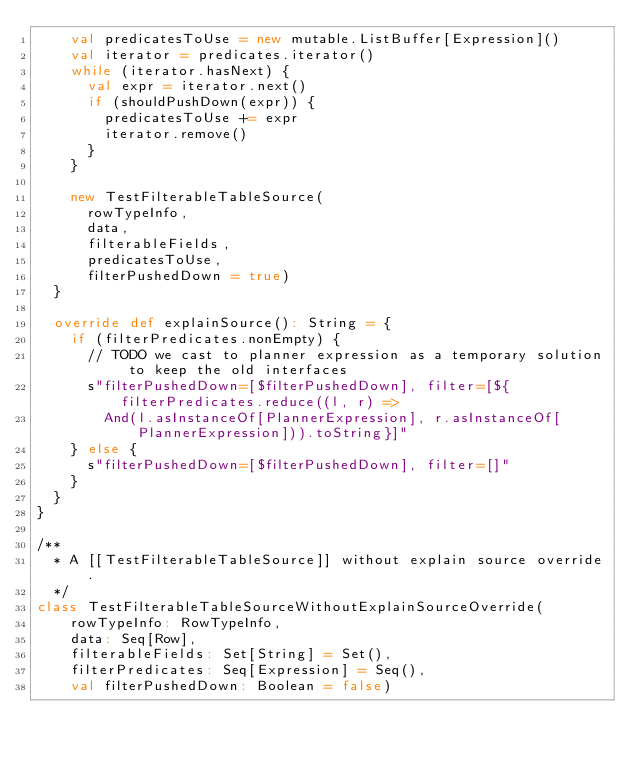<code> <loc_0><loc_0><loc_500><loc_500><_Scala_>    val predicatesToUse = new mutable.ListBuffer[Expression]()
    val iterator = predicates.iterator()
    while (iterator.hasNext) {
      val expr = iterator.next()
      if (shouldPushDown(expr)) {
        predicatesToUse += expr
        iterator.remove()
      }
    }

    new TestFilterableTableSource(
      rowTypeInfo,
      data,
      filterableFields,
      predicatesToUse,
      filterPushedDown = true)
  }

  override def explainSource(): String = {
    if (filterPredicates.nonEmpty) {
      // TODO we cast to planner expression as a temporary solution to keep the old interfaces
      s"filterPushedDown=[$filterPushedDown], filter=[${filterPredicates.reduce((l, r) =>
        And(l.asInstanceOf[PlannerExpression], r.asInstanceOf[PlannerExpression])).toString}]"
    } else {
      s"filterPushedDown=[$filterPushedDown], filter=[]"
    }
  }
}

/**
  * A [[TestFilterableTableSource]] without explain source override.
  */
class TestFilterableTableSourceWithoutExplainSourceOverride(
    rowTypeInfo: RowTypeInfo,
    data: Seq[Row],
    filterableFields: Set[String] = Set(),
    filterPredicates: Seq[Expression] = Seq(),
    val filterPushedDown: Boolean = false)</code> 